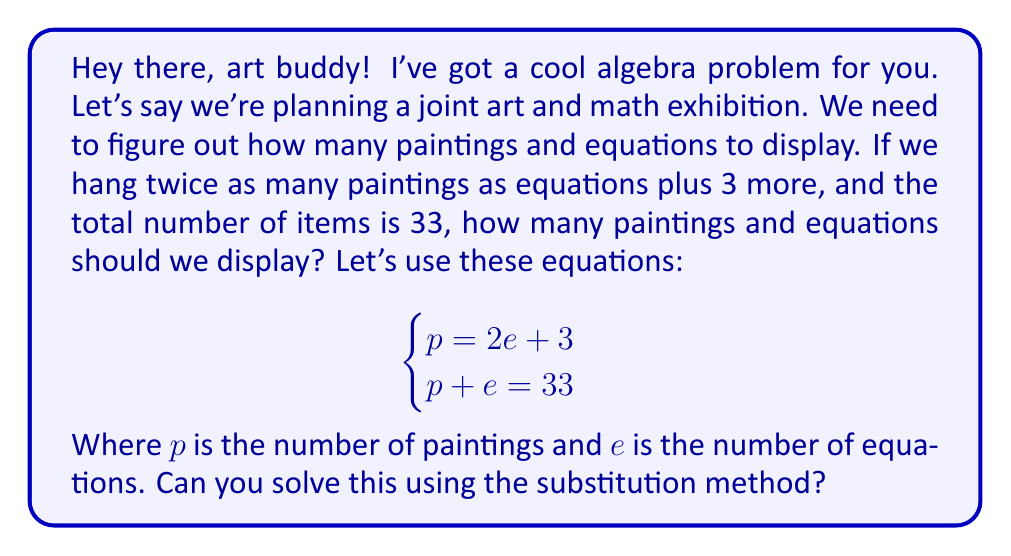Help me with this question. Alright, let's solve this step-by-step using the substitution method:

1) We have two equations:
   $$\begin{cases}
   p = 2e + 3 \\
   p + e = 33
   \end{cases}$$

2) Let's substitute the expression for $p$ from the first equation into the second equation:
   $$(2e + 3) + e = 33$$

3) Now we have one equation with one unknown:
   $$2e + 3 + e = 33$$

4) Simplify by combining like terms:
   $$3e + 3 = 33$$

5) Subtract 3 from both sides:
   $$3e = 30$$

6) Divide both sides by 3:
   $$e = 10$$

7) Now that we know $e = 10$, we can substitute this back into either of the original equations to find $p$. Let's use the first equation:
   $$p = 2e + 3$$
   $$p = 2(10) + 3$$
   $$p = 20 + 3 = 23$$

8) Let's verify our solution satisfies both original equations:
   - $p = 2e + 3$: $23 = 2(10) + 3$ ✓
   - $p + e = 33$: $23 + 10 = 33$ ✓
Answer: We should display 23 paintings $(p = 23)$ and 10 equations $(e = 10)$ in our exhibition. 